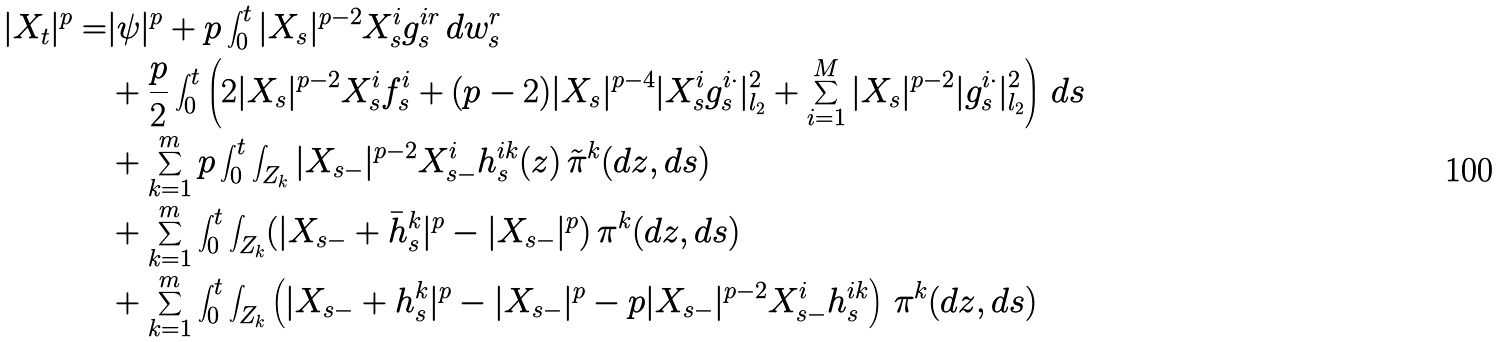<formula> <loc_0><loc_0><loc_500><loc_500>| X _ { t } | ^ { p } = & | \psi | ^ { p } + p \int _ { 0 } ^ { t } | X _ { s } | ^ { p - 2 } X ^ { i } _ { s } g _ { s } ^ { i r } \, d w _ { s } ^ { r } \\ & + \frac { p } { 2 } \int _ { 0 } ^ { t } \left ( 2 | X _ { s } | ^ { p - 2 } X ^ { i } _ { s } f ^ { i } _ { s } + ( p - 2 ) | X _ { s } | ^ { p - 4 } | X ^ { i } _ { s } g ^ { i \cdot } _ { s } | _ { l _ { 2 } } ^ { 2 } + \sum _ { i = 1 } ^ { M } | X _ { s } | ^ { p - 2 } | g ^ { i \cdot } _ { s } | _ { l _ { 2 } } ^ { 2 } \right ) \, d s \\ & + \sum _ { k = 1 } ^ { m } p \int _ { 0 } ^ { t } \int _ { Z _ { k } } | X _ { s - } | ^ { p - 2 } X ^ { i } _ { s - } h ^ { i k } _ { s } ( z ) \, \tilde { \pi } ^ { k } ( d z , d s ) \\ & + \sum _ { k = 1 } ^ { m } \int _ { 0 } ^ { t } \int _ { Z _ { k } } ( | X _ { s - } + \bar { h } ^ { k } _ { s } | ^ { p } - | X _ { s - } | ^ { p } ) \, \pi ^ { k } ( d z , d s ) \\ & + \sum _ { k = 1 } ^ { m } \int _ { 0 } ^ { t } \int _ { Z _ { k } } \left ( | X _ { s - } + h ^ { k } _ { s } | ^ { p } - | X _ { s - } | ^ { p } - p | X _ { s - } | ^ { p - 2 } X ^ { i } _ { s - } h ^ { i k } _ { s } \right ) \, \pi ^ { k } ( d z , d s )</formula> 